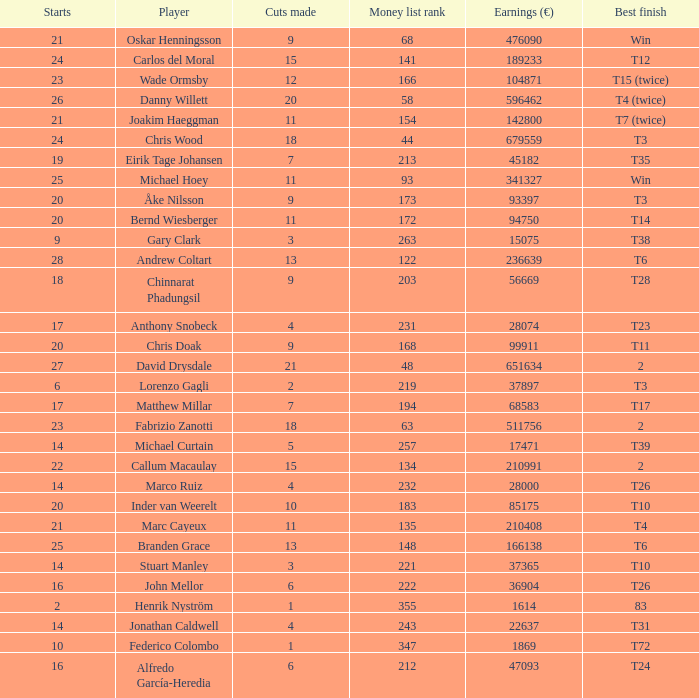How many cuts did Bernd Wiesberger make? 11.0. 